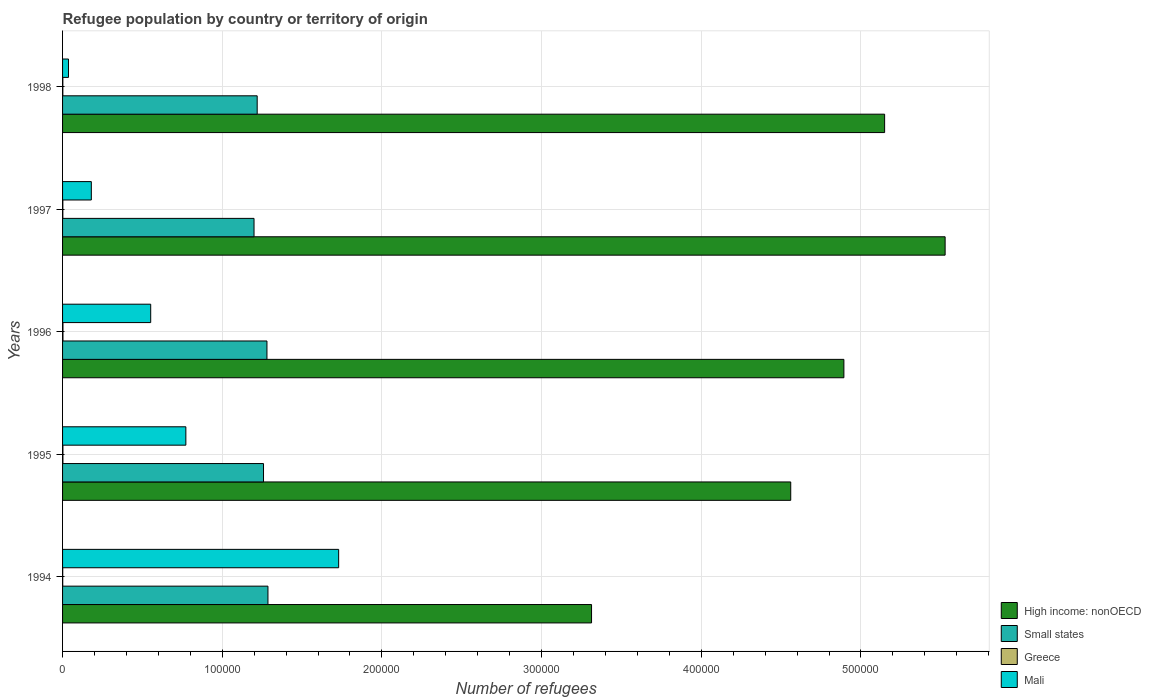How many groups of bars are there?
Offer a terse response. 5. What is the label of the 1st group of bars from the top?
Give a very brief answer. 1998. In how many cases, is the number of bars for a given year not equal to the number of legend labels?
Keep it short and to the point. 0. What is the number of refugees in Small states in 1998?
Your answer should be compact. 1.22e+05. Across all years, what is the maximum number of refugees in Greece?
Make the answer very short. 250. Across all years, what is the minimum number of refugees in Greece?
Make the answer very short. 94. In which year was the number of refugees in Greece maximum?
Your answer should be compact. 1996. What is the total number of refugees in Greece in the graph?
Offer a very short reply. 918. What is the difference between the number of refugees in Mali in 1997 and that in 1998?
Offer a terse response. 1.43e+04. What is the difference between the number of refugees in Greece in 1994 and the number of refugees in High income: nonOECD in 1996?
Your answer should be compact. -4.89e+05. What is the average number of refugees in High income: nonOECD per year?
Ensure brevity in your answer.  4.69e+05. In the year 1995, what is the difference between the number of refugees in Small states and number of refugees in Mali?
Provide a succinct answer. 4.86e+04. In how many years, is the number of refugees in Small states greater than 160000 ?
Your answer should be compact. 0. What is the ratio of the number of refugees in High income: nonOECD in 1995 to that in 1997?
Give a very brief answer. 0.83. What is the difference between the highest and the second highest number of refugees in Mali?
Make the answer very short. 9.57e+04. What is the difference between the highest and the lowest number of refugees in High income: nonOECD?
Provide a succinct answer. 2.21e+05. What does the 1st bar from the bottom in 1995 represents?
Keep it short and to the point. High income: nonOECD. Is it the case that in every year, the sum of the number of refugees in Small states and number of refugees in Mali is greater than the number of refugees in High income: nonOECD?
Your answer should be very brief. No. How many bars are there?
Give a very brief answer. 20. How many years are there in the graph?
Your answer should be compact. 5. Are the values on the major ticks of X-axis written in scientific E-notation?
Offer a very short reply. No. Does the graph contain grids?
Your response must be concise. Yes. Where does the legend appear in the graph?
Offer a very short reply. Bottom right. How many legend labels are there?
Keep it short and to the point. 4. How are the legend labels stacked?
Your answer should be compact. Vertical. What is the title of the graph?
Keep it short and to the point. Refugee population by country or territory of origin. Does "United States" appear as one of the legend labels in the graph?
Your answer should be compact. No. What is the label or title of the X-axis?
Offer a terse response. Number of refugees. What is the label or title of the Y-axis?
Your answer should be very brief. Years. What is the Number of refugees of High income: nonOECD in 1994?
Ensure brevity in your answer.  3.31e+05. What is the Number of refugees of Small states in 1994?
Ensure brevity in your answer.  1.29e+05. What is the Number of refugees in Greece in 1994?
Provide a succinct answer. 94. What is the Number of refugees of Mali in 1994?
Your response must be concise. 1.73e+05. What is the Number of refugees of High income: nonOECD in 1995?
Your response must be concise. 4.56e+05. What is the Number of refugees of Small states in 1995?
Give a very brief answer. 1.26e+05. What is the Number of refugees in Greece in 1995?
Make the answer very short. 222. What is the Number of refugees in Mali in 1995?
Keep it short and to the point. 7.72e+04. What is the Number of refugees of High income: nonOECD in 1996?
Keep it short and to the point. 4.89e+05. What is the Number of refugees of Small states in 1996?
Offer a very short reply. 1.28e+05. What is the Number of refugees in Greece in 1996?
Your response must be concise. 250. What is the Number of refugees in Mali in 1996?
Provide a short and direct response. 5.52e+04. What is the Number of refugees of High income: nonOECD in 1997?
Make the answer very short. 5.53e+05. What is the Number of refugees in Small states in 1997?
Keep it short and to the point. 1.20e+05. What is the Number of refugees of Greece in 1997?
Keep it short and to the point. 178. What is the Number of refugees in Mali in 1997?
Your answer should be very brief. 1.80e+04. What is the Number of refugees in High income: nonOECD in 1998?
Provide a succinct answer. 5.15e+05. What is the Number of refugees of Small states in 1998?
Provide a succinct answer. 1.22e+05. What is the Number of refugees of Greece in 1998?
Your answer should be compact. 174. What is the Number of refugees in Mali in 1998?
Keep it short and to the point. 3702. Across all years, what is the maximum Number of refugees in High income: nonOECD?
Give a very brief answer. 5.53e+05. Across all years, what is the maximum Number of refugees of Small states?
Provide a short and direct response. 1.29e+05. Across all years, what is the maximum Number of refugees in Greece?
Your answer should be very brief. 250. Across all years, what is the maximum Number of refugees in Mali?
Ensure brevity in your answer.  1.73e+05. Across all years, what is the minimum Number of refugees of High income: nonOECD?
Your answer should be very brief. 3.31e+05. Across all years, what is the minimum Number of refugees in Small states?
Keep it short and to the point. 1.20e+05. Across all years, what is the minimum Number of refugees of Greece?
Keep it short and to the point. 94. Across all years, what is the minimum Number of refugees in Mali?
Offer a very short reply. 3702. What is the total Number of refugees of High income: nonOECD in the graph?
Provide a short and direct response. 2.34e+06. What is the total Number of refugees of Small states in the graph?
Make the answer very short. 6.24e+05. What is the total Number of refugees of Greece in the graph?
Offer a very short reply. 918. What is the total Number of refugees of Mali in the graph?
Provide a short and direct response. 3.27e+05. What is the difference between the Number of refugees of High income: nonOECD in 1994 and that in 1995?
Keep it short and to the point. -1.25e+05. What is the difference between the Number of refugees of Small states in 1994 and that in 1995?
Ensure brevity in your answer.  2778. What is the difference between the Number of refugees in Greece in 1994 and that in 1995?
Offer a terse response. -128. What is the difference between the Number of refugees in Mali in 1994 and that in 1995?
Keep it short and to the point. 9.57e+04. What is the difference between the Number of refugees in High income: nonOECD in 1994 and that in 1996?
Offer a very short reply. -1.58e+05. What is the difference between the Number of refugees of Small states in 1994 and that in 1996?
Provide a succinct answer. 622. What is the difference between the Number of refugees in Greece in 1994 and that in 1996?
Ensure brevity in your answer.  -156. What is the difference between the Number of refugees in Mali in 1994 and that in 1996?
Provide a succinct answer. 1.18e+05. What is the difference between the Number of refugees in High income: nonOECD in 1994 and that in 1997?
Give a very brief answer. -2.21e+05. What is the difference between the Number of refugees in Small states in 1994 and that in 1997?
Ensure brevity in your answer.  8719. What is the difference between the Number of refugees of Greece in 1994 and that in 1997?
Make the answer very short. -84. What is the difference between the Number of refugees of Mali in 1994 and that in 1997?
Make the answer very short. 1.55e+05. What is the difference between the Number of refugees of High income: nonOECD in 1994 and that in 1998?
Ensure brevity in your answer.  -1.84e+05. What is the difference between the Number of refugees in Small states in 1994 and that in 1998?
Your response must be concise. 6742. What is the difference between the Number of refugees of Greece in 1994 and that in 1998?
Your response must be concise. -80. What is the difference between the Number of refugees of Mali in 1994 and that in 1998?
Your answer should be very brief. 1.69e+05. What is the difference between the Number of refugees in High income: nonOECD in 1995 and that in 1996?
Give a very brief answer. -3.33e+04. What is the difference between the Number of refugees in Small states in 1995 and that in 1996?
Your answer should be very brief. -2156. What is the difference between the Number of refugees of Greece in 1995 and that in 1996?
Keep it short and to the point. -28. What is the difference between the Number of refugees in Mali in 1995 and that in 1996?
Your answer should be very brief. 2.20e+04. What is the difference between the Number of refugees in High income: nonOECD in 1995 and that in 1997?
Your response must be concise. -9.67e+04. What is the difference between the Number of refugees of Small states in 1995 and that in 1997?
Make the answer very short. 5941. What is the difference between the Number of refugees of Mali in 1995 and that in 1997?
Provide a short and direct response. 5.92e+04. What is the difference between the Number of refugees in High income: nonOECD in 1995 and that in 1998?
Provide a short and direct response. -5.88e+04. What is the difference between the Number of refugees of Small states in 1995 and that in 1998?
Provide a succinct answer. 3964. What is the difference between the Number of refugees in Greece in 1995 and that in 1998?
Give a very brief answer. 48. What is the difference between the Number of refugees of Mali in 1995 and that in 1998?
Ensure brevity in your answer.  7.35e+04. What is the difference between the Number of refugees of High income: nonOECD in 1996 and that in 1997?
Provide a short and direct response. -6.34e+04. What is the difference between the Number of refugees in Small states in 1996 and that in 1997?
Give a very brief answer. 8097. What is the difference between the Number of refugees of Greece in 1996 and that in 1997?
Your answer should be compact. 72. What is the difference between the Number of refugees in Mali in 1996 and that in 1997?
Ensure brevity in your answer.  3.72e+04. What is the difference between the Number of refugees of High income: nonOECD in 1996 and that in 1998?
Ensure brevity in your answer.  -2.55e+04. What is the difference between the Number of refugees of Small states in 1996 and that in 1998?
Keep it short and to the point. 6120. What is the difference between the Number of refugees of Greece in 1996 and that in 1998?
Offer a terse response. 76. What is the difference between the Number of refugees of Mali in 1996 and that in 1998?
Give a very brief answer. 5.15e+04. What is the difference between the Number of refugees in High income: nonOECD in 1997 and that in 1998?
Offer a terse response. 3.79e+04. What is the difference between the Number of refugees in Small states in 1997 and that in 1998?
Offer a terse response. -1977. What is the difference between the Number of refugees of Mali in 1997 and that in 1998?
Provide a short and direct response. 1.43e+04. What is the difference between the Number of refugees of High income: nonOECD in 1994 and the Number of refugees of Small states in 1995?
Your answer should be very brief. 2.05e+05. What is the difference between the Number of refugees in High income: nonOECD in 1994 and the Number of refugees in Greece in 1995?
Make the answer very short. 3.31e+05. What is the difference between the Number of refugees of High income: nonOECD in 1994 and the Number of refugees of Mali in 1995?
Provide a succinct answer. 2.54e+05. What is the difference between the Number of refugees of Small states in 1994 and the Number of refugees of Greece in 1995?
Offer a very short reply. 1.28e+05. What is the difference between the Number of refugees in Small states in 1994 and the Number of refugees in Mali in 1995?
Keep it short and to the point. 5.14e+04. What is the difference between the Number of refugees of Greece in 1994 and the Number of refugees of Mali in 1995?
Offer a very short reply. -7.71e+04. What is the difference between the Number of refugees of High income: nonOECD in 1994 and the Number of refugees of Small states in 1996?
Offer a terse response. 2.03e+05. What is the difference between the Number of refugees in High income: nonOECD in 1994 and the Number of refugees in Greece in 1996?
Offer a terse response. 3.31e+05. What is the difference between the Number of refugees in High income: nonOECD in 1994 and the Number of refugees in Mali in 1996?
Provide a succinct answer. 2.76e+05. What is the difference between the Number of refugees of Small states in 1994 and the Number of refugees of Greece in 1996?
Your answer should be very brief. 1.28e+05. What is the difference between the Number of refugees in Small states in 1994 and the Number of refugees in Mali in 1996?
Make the answer very short. 7.34e+04. What is the difference between the Number of refugees of Greece in 1994 and the Number of refugees of Mali in 1996?
Your answer should be compact. -5.51e+04. What is the difference between the Number of refugees of High income: nonOECD in 1994 and the Number of refugees of Small states in 1997?
Provide a succinct answer. 2.11e+05. What is the difference between the Number of refugees in High income: nonOECD in 1994 and the Number of refugees in Greece in 1997?
Make the answer very short. 3.31e+05. What is the difference between the Number of refugees in High income: nonOECD in 1994 and the Number of refugees in Mali in 1997?
Ensure brevity in your answer.  3.13e+05. What is the difference between the Number of refugees in Small states in 1994 and the Number of refugees in Greece in 1997?
Your answer should be very brief. 1.28e+05. What is the difference between the Number of refugees of Small states in 1994 and the Number of refugees of Mali in 1997?
Provide a succinct answer. 1.11e+05. What is the difference between the Number of refugees in Greece in 1994 and the Number of refugees in Mali in 1997?
Your answer should be compact. -1.79e+04. What is the difference between the Number of refugees in High income: nonOECD in 1994 and the Number of refugees in Small states in 1998?
Provide a short and direct response. 2.09e+05. What is the difference between the Number of refugees of High income: nonOECD in 1994 and the Number of refugees of Greece in 1998?
Your answer should be compact. 3.31e+05. What is the difference between the Number of refugees in High income: nonOECD in 1994 and the Number of refugees in Mali in 1998?
Your answer should be compact. 3.28e+05. What is the difference between the Number of refugees in Small states in 1994 and the Number of refugees in Greece in 1998?
Offer a terse response. 1.28e+05. What is the difference between the Number of refugees of Small states in 1994 and the Number of refugees of Mali in 1998?
Keep it short and to the point. 1.25e+05. What is the difference between the Number of refugees in Greece in 1994 and the Number of refugees in Mali in 1998?
Provide a succinct answer. -3608. What is the difference between the Number of refugees in High income: nonOECD in 1995 and the Number of refugees in Small states in 1996?
Provide a succinct answer. 3.28e+05. What is the difference between the Number of refugees of High income: nonOECD in 1995 and the Number of refugees of Greece in 1996?
Your response must be concise. 4.56e+05. What is the difference between the Number of refugees in High income: nonOECD in 1995 and the Number of refugees in Mali in 1996?
Your response must be concise. 4.01e+05. What is the difference between the Number of refugees of Small states in 1995 and the Number of refugees of Greece in 1996?
Your response must be concise. 1.26e+05. What is the difference between the Number of refugees of Small states in 1995 and the Number of refugees of Mali in 1996?
Ensure brevity in your answer.  7.06e+04. What is the difference between the Number of refugees in Greece in 1995 and the Number of refugees in Mali in 1996?
Your response must be concise. -5.50e+04. What is the difference between the Number of refugees in High income: nonOECD in 1995 and the Number of refugees in Small states in 1997?
Your answer should be compact. 3.36e+05. What is the difference between the Number of refugees in High income: nonOECD in 1995 and the Number of refugees in Greece in 1997?
Provide a short and direct response. 4.56e+05. What is the difference between the Number of refugees of High income: nonOECD in 1995 and the Number of refugees of Mali in 1997?
Your answer should be very brief. 4.38e+05. What is the difference between the Number of refugees of Small states in 1995 and the Number of refugees of Greece in 1997?
Make the answer very short. 1.26e+05. What is the difference between the Number of refugees in Small states in 1995 and the Number of refugees in Mali in 1997?
Provide a succinct answer. 1.08e+05. What is the difference between the Number of refugees in Greece in 1995 and the Number of refugees in Mali in 1997?
Ensure brevity in your answer.  -1.78e+04. What is the difference between the Number of refugees of High income: nonOECD in 1995 and the Number of refugees of Small states in 1998?
Your response must be concise. 3.34e+05. What is the difference between the Number of refugees in High income: nonOECD in 1995 and the Number of refugees in Greece in 1998?
Your response must be concise. 4.56e+05. What is the difference between the Number of refugees in High income: nonOECD in 1995 and the Number of refugees in Mali in 1998?
Make the answer very short. 4.52e+05. What is the difference between the Number of refugees of Small states in 1995 and the Number of refugees of Greece in 1998?
Your answer should be compact. 1.26e+05. What is the difference between the Number of refugees in Small states in 1995 and the Number of refugees in Mali in 1998?
Provide a succinct answer. 1.22e+05. What is the difference between the Number of refugees in Greece in 1995 and the Number of refugees in Mali in 1998?
Make the answer very short. -3480. What is the difference between the Number of refugees in High income: nonOECD in 1996 and the Number of refugees in Small states in 1997?
Give a very brief answer. 3.69e+05. What is the difference between the Number of refugees of High income: nonOECD in 1996 and the Number of refugees of Greece in 1997?
Make the answer very short. 4.89e+05. What is the difference between the Number of refugees in High income: nonOECD in 1996 and the Number of refugees in Mali in 1997?
Your answer should be compact. 4.71e+05. What is the difference between the Number of refugees of Small states in 1996 and the Number of refugees of Greece in 1997?
Provide a succinct answer. 1.28e+05. What is the difference between the Number of refugees of Small states in 1996 and the Number of refugees of Mali in 1997?
Provide a short and direct response. 1.10e+05. What is the difference between the Number of refugees of Greece in 1996 and the Number of refugees of Mali in 1997?
Provide a short and direct response. -1.78e+04. What is the difference between the Number of refugees in High income: nonOECD in 1996 and the Number of refugees in Small states in 1998?
Make the answer very short. 3.67e+05. What is the difference between the Number of refugees in High income: nonOECD in 1996 and the Number of refugees in Greece in 1998?
Keep it short and to the point. 4.89e+05. What is the difference between the Number of refugees in High income: nonOECD in 1996 and the Number of refugees in Mali in 1998?
Your response must be concise. 4.86e+05. What is the difference between the Number of refugees of Small states in 1996 and the Number of refugees of Greece in 1998?
Offer a terse response. 1.28e+05. What is the difference between the Number of refugees of Small states in 1996 and the Number of refugees of Mali in 1998?
Your response must be concise. 1.24e+05. What is the difference between the Number of refugees of Greece in 1996 and the Number of refugees of Mali in 1998?
Your response must be concise. -3452. What is the difference between the Number of refugees in High income: nonOECD in 1997 and the Number of refugees in Small states in 1998?
Your response must be concise. 4.31e+05. What is the difference between the Number of refugees in High income: nonOECD in 1997 and the Number of refugees in Greece in 1998?
Keep it short and to the point. 5.53e+05. What is the difference between the Number of refugees of High income: nonOECD in 1997 and the Number of refugees of Mali in 1998?
Your answer should be very brief. 5.49e+05. What is the difference between the Number of refugees of Small states in 1997 and the Number of refugees of Greece in 1998?
Ensure brevity in your answer.  1.20e+05. What is the difference between the Number of refugees of Small states in 1997 and the Number of refugees of Mali in 1998?
Provide a short and direct response. 1.16e+05. What is the difference between the Number of refugees of Greece in 1997 and the Number of refugees of Mali in 1998?
Your response must be concise. -3524. What is the average Number of refugees of High income: nonOECD per year?
Make the answer very short. 4.69e+05. What is the average Number of refugees of Small states per year?
Your answer should be compact. 1.25e+05. What is the average Number of refugees of Greece per year?
Offer a terse response. 183.6. What is the average Number of refugees of Mali per year?
Keep it short and to the point. 6.54e+04. In the year 1994, what is the difference between the Number of refugees of High income: nonOECD and Number of refugees of Small states?
Keep it short and to the point. 2.03e+05. In the year 1994, what is the difference between the Number of refugees of High income: nonOECD and Number of refugees of Greece?
Your answer should be very brief. 3.31e+05. In the year 1994, what is the difference between the Number of refugees of High income: nonOECD and Number of refugees of Mali?
Ensure brevity in your answer.  1.58e+05. In the year 1994, what is the difference between the Number of refugees in Small states and Number of refugees in Greece?
Offer a terse response. 1.29e+05. In the year 1994, what is the difference between the Number of refugees in Small states and Number of refugees in Mali?
Keep it short and to the point. -4.43e+04. In the year 1994, what is the difference between the Number of refugees in Greece and Number of refugees in Mali?
Give a very brief answer. -1.73e+05. In the year 1995, what is the difference between the Number of refugees in High income: nonOECD and Number of refugees in Small states?
Make the answer very short. 3.30e+05. In the year 1995, what is the difference between the Number of refugees in High income: nonOECD and Number of refugees in Greece?
Your response must be concise. 4.56e+05. In the year 1995, what is the difference between the Number of refugees of High income: nonOECD and Number of refugees of Mali?
Your answer should be compact. 3.79e+05. In the year 1995, what is the difference between the Number of refugees in Small states and Number of refugees in Greece?
Your answer should be very brief. 1.26e+05. In the year 1995, what is the difference between the Number of refugees of Small states and Number of refugees of Mali?
Offer a very short reply. 4.86e+04. In the year 1995, what is the difference between the Number of refugees of Greece and Number of refugees of Mali?
Ensure brevity in your answer.  -7.70e+04. In the year 1996, what is the difference between the Number of refugees in High income: nonOECD and Number of refugees in Small states?
Your response must be concise. 3.61e+05. In the year 1996, what is the difference between the Number of refugees in High income: nonOECD and Number of refugees in Greece?
Give a very brief answer. 4.89e+05. In the year 1996, what is the difference between the Number of refugees in High income: nonOECD and Number of refugees in Mali?
Offer a terse response. 4.34e+05. In the year 1996, what is the difference between the Number of refugees in Small states and Number of refugees in Greece?
Your response must be concise. 1.28e+05. In the year 1996, what is the difference between the Number of refugees in Small states and Number of refugees in Mali?
Offer a very short reply. 7.28e+04. In the year 1996, what is the difference between the Number of refugees in Greece and Number of refugees in Mali?
Your answer should be very brief. -5.49e+04. In the year 1997, what is the difference between the Number of refugees of High income: nonOECD and Number of refugees of Small states?
Provide a succinct answer. 4.33e+05. In the year 1997, what is the difference between the Number of refugees in High income: nonOECD and Number of refugees in Greece?
Ensure brevity in your answer.  5.53e+05. In the year 1997, what is the difference between the Number of refugees in High income: nonOECD and Number of refugees in Mali?
Your answer should be very brief. 5.35e+05. In the year 1997, what is the difference between the Number of refugees in Small states and Number of refugees in Greece?
Keep it short and to the point. 1.20e+05. In the year 1997, what is the difference between the Number of refugees in Small states and Number of refugees in Mali?
Ensure brevity in your answer.  1.02e+05. In the year 1997, what is the difference between the Number of refugees in Greece and Number of refugees in Mali?
Your answer should be compact. -1.78e+04. In the year 1998, what is the difference between the Number of refugees of High income: nonOECD and Number of refugees of Small states?
Your answer should be very brief. 3.93e+05. In the year 1998, what is the difference between the Number of refugees of High income: nonOECD and Number of refugees of Greece?
Offer a terse response. 5.15e+05. In the year 1998, what is the difference between the Number of refugees in High income: nonOECD and Number of refugees in Mali?
Provide a short and direct response. 5.11e+05. In the year 1998, what is the difference between the Number of refugees of Small states and Number of refugees of Greece?
Your answer should be very brief. 1.22e+05. In the year 1998, what is the difference between the Number of refugees of Small states and Number of refugees of Mali?
Ensure brevity in your answer.  1.18e+05. In the year 1998, what is the difference between the Number of refugees in Greece and Number of refugees in Mali?
Offer a terse response. -3528. What is the ratio of the Number of refugees in High income: nonOECD in 1994 to that in 1995?
Your response must be concise. 0.73. What is the ratio of the Number of refugees in Small states in 1994 to that in 1995?
Offer a very short reply. 1.02. What is the ratio of the Number of refugees in Greece in 1994 to that in 1995?
Offer a very short reply. 0.42. What is the ratio of the Number of refugees in Mali in 1994 to that in 1995?
Keep it short and to the point. 2.24. What is the ratio of the Number of refugees of High income: nonOECD in 1994 to that in 1996?
Provide a succinct answer. 0.68. What is the ratio of the Number of refugees in Greece in 1994 to that in 1996?
Your answer should be very brief. 0.38. What is the ratio of the Number of refugees in Mali in 1994 to that in 1996?
Ensure brevity in your answer.  3.13. What is the ratio of the Number of refugees in High income: nonOECD in 1994 to that in 1997?
Offer a terse response. 0.6. What is the ratio of the Number of refugees in Small states in 1994 to that in 1997?
Offer a very short reply. 1.07. What is the ratio of the Number of refugees in Greece in 1994 to that in 1997?
Make the answer very short. 0.53. What is the ratio of the Number of refugees in Mali in 1994 to that in 1997?
Make the answer very short. 9.6. What is the ratio of the Number of refugees of High income: nonOECD in 1994 to that in 1998?
Provide a short and direct response. 0.64. What is the ratio of the Number of refugees of Small states in 1994 to that in 1998?
Make the answer very short. 1.06. What is the ratio of the Number of refugees of Greece in 1994 to that in 1998?
Offer a terse response. 0.54. What is the ratio of the Number of refugees in Mali in 1994 to that in 1998?
Ensure brevity in your answer.  46.71. What is the ratio of the Number of refugees of High income: nonOECD in 1995 to that in 1996?
Provide a succinct answer. 0.93. What is the ratio of the Number of refugees of Small states in 1995 to that in 1996?
Your answer should be very brief. 0.98. What is the ratio of the Number of refugees of Greece in 1995 to that in 1996?
Ensure brevity in your answer.  0.89. What is the ratio of the Number of refugees of Mali in 1995 to that in 1996?
Ensure brevity in your answer.  1.4. What is the ratio of the Number of refugees of High income: nonOECD in 1995 to that in 1997?
Offer a very short reply. 0.83. What is the ratio of the Number of refugees in Small states in 1995 to that in 1997?
Your answer should be very brief. 1.05. What is the ratio of the Number of refugees of Greece in 1995 to that in 1997?
Provide a succinct answer. 1.25. What is the ratio of the Number of refugees of Mali in 1995 to that in 1997?
Your answer should be very brief. 4.29. What is the ratio of the Number of refugees in High income: nonOECD in 1995 to that in 1998?
Give a very brief answer. 0.89. What is the ratio of the Number of refugees in Small states in 1995 to that in 1998?
Ensure brevity in your answer.  1.03. What is the ratio of the Number of refugees in Greece in 1995 to that in 1998?
Your response must be concise. 1.28. What is the ratio of the Number of refugees of Mali in 1995 to that in 1998?
Your answer should be compact. 20.86. What is the ratio of the Number of refugees in High income: nonOECD in 1996 to that in 1997?
Offer a terse response. 0.89. What is the ratio of the Number of refugees in Small states in 1996 to that in 1997?
Make the answer very short. 1.07. What is the ratio of the Number of refugees in Greece in 1996 to that in 1997?
Provide a succinct answer. 1.4. What is the ratio of the Number of refugees in Mali in 1996 to that in 1997?
Keep it short and to the point. 3.06. What is the ratio of the Number of refugees of High income: nonOECD in 1996 to that in 1998?
Provide a succinct answer. 0.95. What is the ratio of the Number of refugees in Small states in 1996 to that in 1998?
Provide a succinct answer. 1.05. What is the ratio of the Number of refugees of Greece in 1996 to that in 1998?
Ensure brevity in your answer.  1.44. What is the ratio of the Number of refugees in Mali in 1996 to that in 1998?
Provide a succinct answer. 14.91. What is the ratio of the Number of refugees of High income: nonOECD in 1997 to that in 1998?
Your answer should be compact. 1.07. What is the ratio of the Number of refugees of Small states in 1997 to that in 1998?
Your answer should be very brief. 0.98. What is the ratio of the Number of refugees of Mali in 1997 to that in 1998?
Your response must be concise. 4.87. What is the difference between the highest and the second highest Number of refugees of High income: nonOECD?
Your answer should be compact. 3.79e+04. What is the difference between the highest and the second highest Number of refugees of Small states?
Your answer should be compact. 622. What is the difference between the highest and the second highest Number of refugees in Greece?
Ensure brevity in your answer.  28. What is the difference between the highest and the second highest Number of refugees of Mali?
Keep it short and to the point. 9.57e+04. What is the difference between the highest and the lowest Number of refugees in High income: nonOECD?
Provide a short and direct response. 2.21e+05. What is the difference between the highest and the lowest Number of refugees in Small states?
Provide a short and direct response. 8719. What is the difference between the highest and the lowest Number of refugees of Greece?
Provide a short and direct response. 156. What is the difference between the highest and the lowest Number of refugees in Mali?
Offer a terse response. 1.69e+05. 